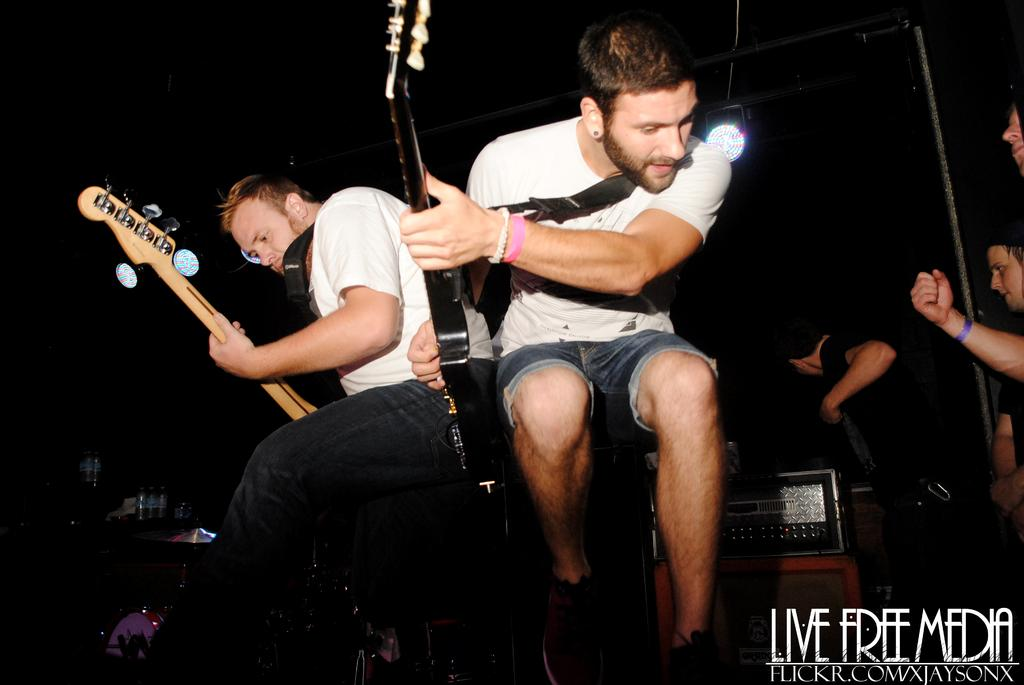How many people are playing musical instruments in the image? There are two men in the image, and they are both playing guitars. What are the men doing on the stage? The men are playing guitars on the stage. Can you describe the describe the audience in the image? There are people standing on the right side of the image, which suggests they are the audience for the performance. What type of cheese is being sorted by the horses in the image? There are no horses or cheese present in the image. How many horses are visible in the image? There are no horses visible in the image. 